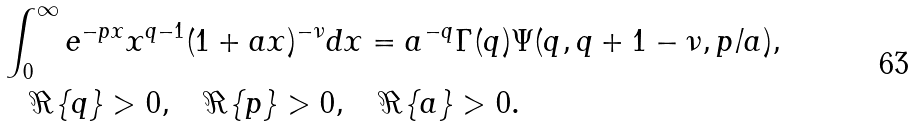Convert formula to latex. <formula><loc_0><loc_0><loc_500><loc_500>& \int _ { 0 } ^ { \infty } e ^ { - p x } x ^ { q - 1 } ( 1 + a x ) ^ { - \nu } d x = a ^ { - q } \Gamma ( q ) \Psi ( q , q + 1 - \nu , p / a ) , \\ & \quad \Re \{ q \} > 0 , \quad \Re \{ p \} > 0 , \quad \Re \{ a \} > 0 . \\</formula> 